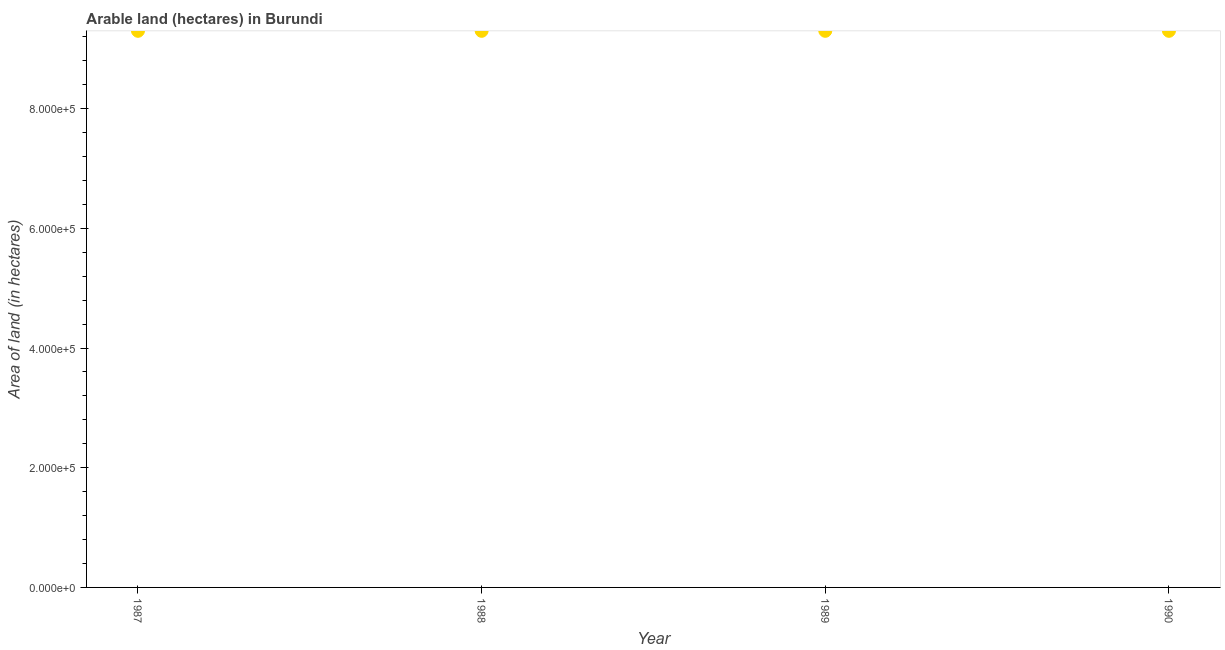What is the area of land in 1988?
Ensure brevity in your answer.  9.30e+05. Across all years, what is the maximum area of land?
Your response must be concise. 9.30e+05. Across all years, what is the minimum area of land?
Your answer should be very brief. 9.30e+05. What is the sum of the area of land?
Provide a succinct answer. 3.72e+06. What is the average area of land per year?
Your response must be concise. 9.30e+05. What is the median area of land?
Ensure brevity in your answer.  9.30e+05. In how many years, is the area of land greater than 600000 hectares?
Offer a very short reply. 4. Do a majority of the years between 1990 and 1989 (inclusive) have area of land greater than 720000 hectares?
Provide a short and direct response. No. Is the area of land in 1987 less than that in 1990?
Your answer should be very brief. No. What is the difference between the highest and the second highest area of land?
Your answer should be very brief. 0. What is the difference between the highest and the lowest area of land?
Provide a short and direct response. 0. In how many years, is the area of land greater than the average area of land taken over all years?
Make the answer very short. 0. Does the area of land monotonically increase over the years?
Ensure brevity in your answer.  No. How many dotlines are there?
Give a very brief answer. 1. Does the graph contain any zero values?
Your answer should be very brief. No. Does the graph contain grids?
Offer a terse response. No. What is the title of the graph?
Your answer should be compact. Arable land (hectares) in Burundi. What is the label or title of the Y-axis?
Keep it short and to the point. Area of land (in hectares). What is the Area of land (in hectares) in 1987?
Make the answer very short. 9.30e+05. What is the Area of land (in hectares) in 1988?
Offer a terse response. 9.30e+05. What is the Area of land (in hectares) in 1989?
Ensure brevity in your answer.  9.30e+05. What is the Area of land (in hectares) in 1990?
Offer a very short reply. 9.30e+05. What is the difference between the Area of land (in hectares) in 1989 and 1990?
Keep it short and to the point. 0. What is the ratio of the Area of land (in hectares) in 1987 to that in 1988?
Your answer should be very brief. 1. What is the ratio of the Area of land (in hectares) in 1988 to that in 1989?
Your answer should be very brief. 1. What is the ratio of the Area of land (in hectares) in 1988 to that in 1990?
Your answer should be compact. 1. What is the ratio of the Area of land (in hectares) in 1989 to that in 1990?
Ensure brevity in your answer.  1. 